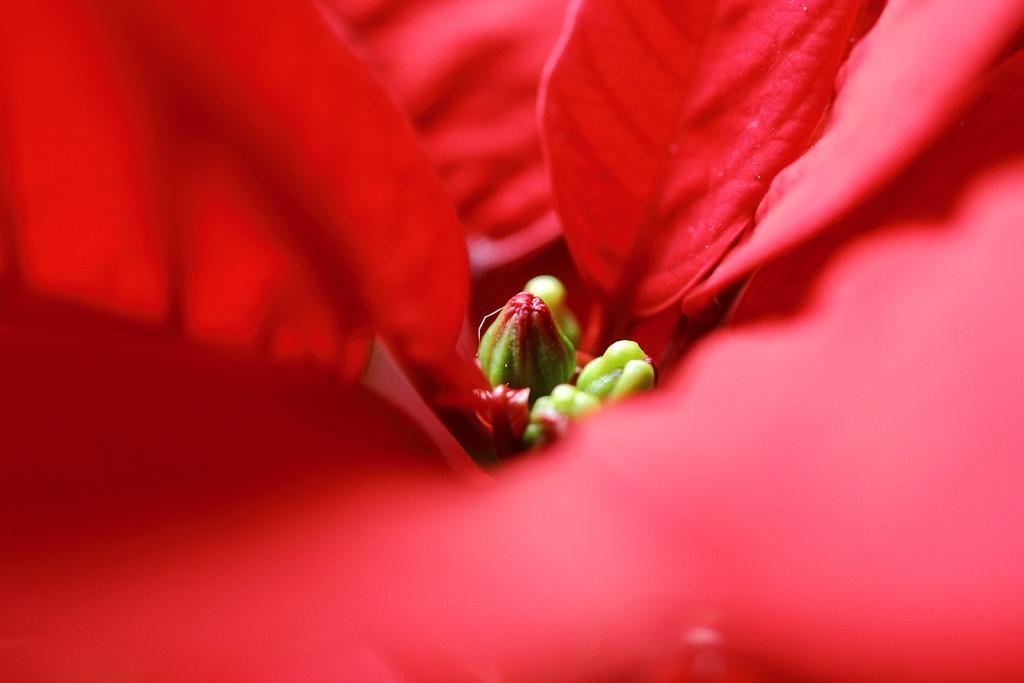Could you give a brief overview of what you see in this image? In the middle it's a bird, these are the red color petals. 